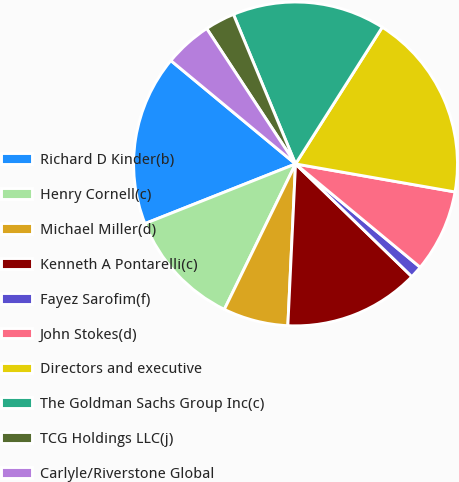<chart> <loc_0><loc_0><loc_500><loc_500><pie_chart><fcel>Richard D Kinder(b)<fcel>Henry Cornell(c)<fcel>Michael Miller(d)<fcel>Kenneth A Pontarelli(c)<fcel>Fayez Sarofim(f)<fcel>John Stokes(d)<fcel>Directors and executive<fcel>The Goldman Sachs Group Inc(c)<fcel>TCG Holdings LLC(j)<fcel>Carlyle/Riverstone Global<nl><fcel>17.02%<fcel>11.75%<fcel>6.49%<fcel>13.51%<fcel>1.23%<fcel>8.25%<fcel>18.77%<fcel>15.26%<fcel>2.98%<fcel>4.74%<nl></chart> 